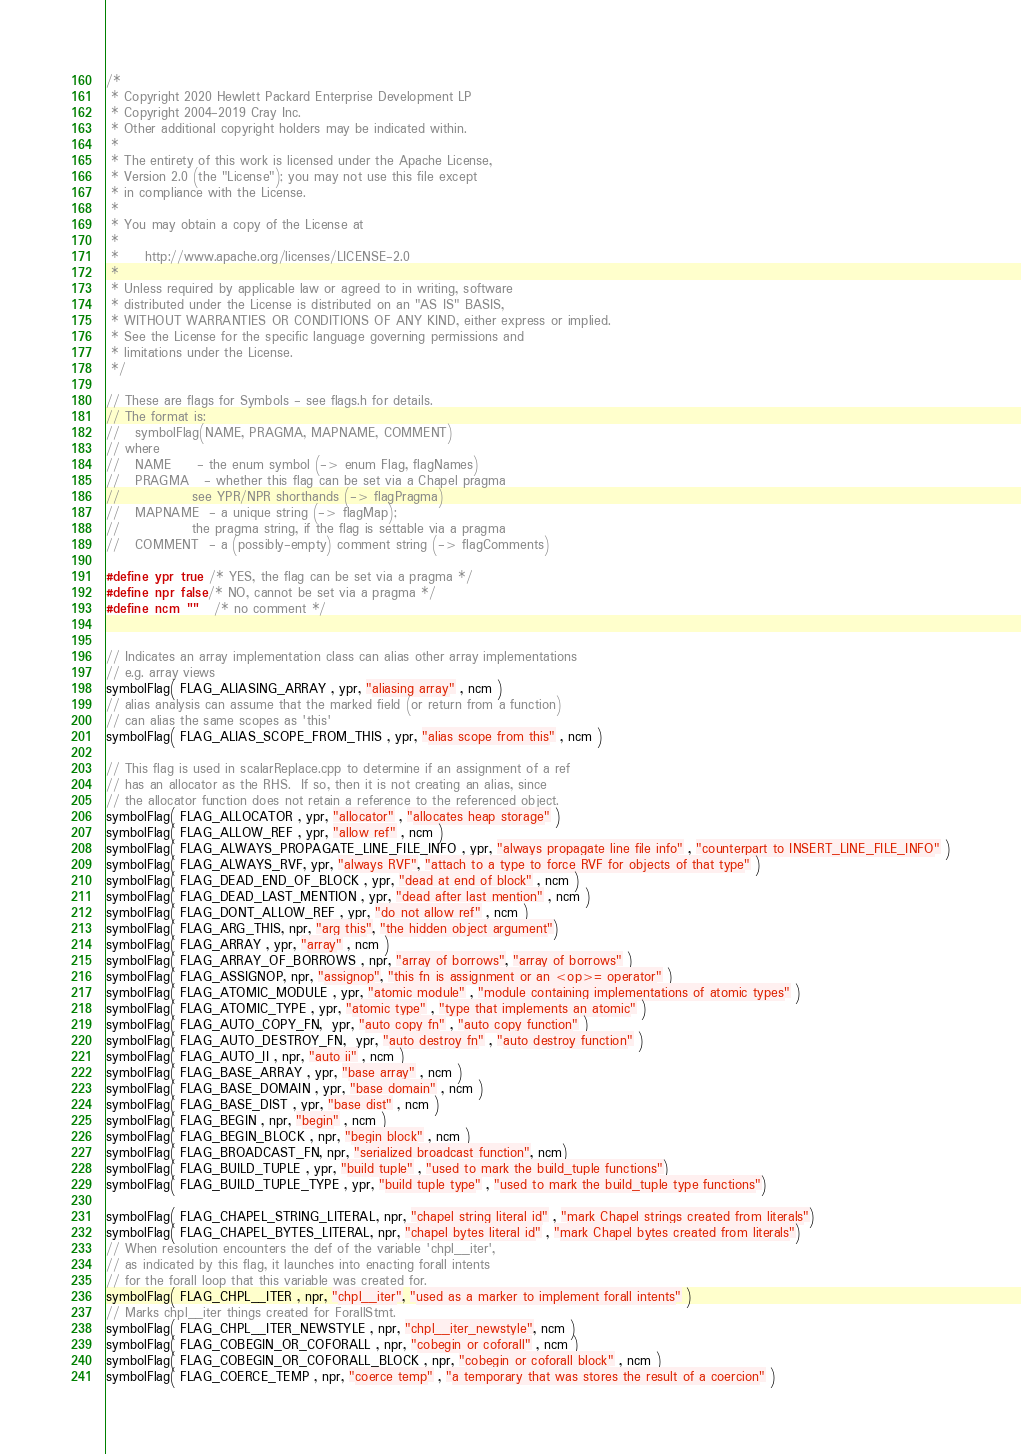<code> <loc_0><loc_0><loc_500><loc_500><_C_>/*
 * Copyright 2020 Hewlett Packard Enterprise Development LP
 * Copyright 2004-2019 Cray Inc.
 * Other additional copyright holders may be indicated within.
 *
 * The entirety of this work is licensed under the Apache License,
 * Version 2.0 (the "License"); you may not use this file except
 * in compliance with the License.
 *
 * You may obtain a copy of the License at
 *
 *     http://www.apache.org/licenses/LICENSE-2.0
 *
 * Unless required by applicable law or agreed to in writing, software
 * distributed under the License is distributed on an "AS IS" BASIS,
 * WITHOUT WARRANTIES OR CONDITIONS OF ANY KIND, either express or implied.
 * See the License for the specific language governing permissions and
 * limitations under the License.
 */

// These are flags for Symbols - see flags.h for details.
// The format is:
//   symbolFlag(NAME, PRAGMA, MAPNAME, COMMENT)
// where
//   NAME     - the enum symbol (-> enum Flag, flagNames)
//   PRAGMA   - whether this flag can be set via a Chapel pragma
//              see YPR/NPR shorthands (-> flagPragma)
//   MAPNAME  - a unique string (-> flagMap);
//              the pragma string, if the flag is settable via a pragma
//   COMMENT  - a (possibly-empty) comment string (-> flagComments)

#define ypr true  /* YES, the flag can be set via a pragma */
#define npr false /* NO, cannot be set via a pragma */
#define ncm ""    /* no comment */


// Indicates an array implementation class can alias other array implementations
// e.g. array views
symbolFlag( FLAG_ALIASING_ARRAY , ypr, "aliasing array" , ncm )
// alias analysis can assume that the marked field (or return from a function)
// can alias the same scopes as 'this'
symbolFlag( FLAG_ALIAS_SCOPE_FROM_THIS , ypr, "alias scope from this" , ncm )

// This flag is used in scalarReplace.cpp to determine if an assignment of a ref
// has an allocator as the RHS.  If so, then it is not creating an alias, since
// the allocator function does not retain a reference to the referenced object.
symbolFlag( FLAG_ALLOCATOR , ypr, "allocator" , "allocates heap storage" )
symbolFlag( FLAG_ALLOW_REF , ypr, "allow ref" , ncm )
symbolFlag( FLAG_ALWAYS_PROPAGATE_LINE_FILE_INFO , ypr, "always propagate line file info" , "counterpart to INSERT_LINE_FILE_INFO" )
symbolFlag( FLAG_ALWAYS_RVF, ypr, "always RVF", "attach to a type to force RVF for objects of that type" )
symbolFlag( FLAG_DEAD_END_OF_BLOCK , ypr, "dead at end of block" , ncm )
symbolFlag( FLAG_DEAD_LAST_MENTION , ypr, "dead after last mention" , ncm )
symbolFlag( FLAG_DONT_ALLOW_REF , ypr, "do not allow ref" , ncm )
symbolFlag( FLAG_ARG_THIS, npr, "arg this", "the hidden object argument")
symbolFlag( FLAG_ARRAY , ypr, "array" , ncm )
symbolFlag( FLAG_ARRAY_OF_BORROWS , npr, "array of borrows", "array of borrows" )
symbolFlag( FLAG_ASSIGNOP, npr, "assignop", "this fn is assignment or an <op>= operator" )
symbolFlag( FLAG_ATOMIC_MODULE , ypr, "atomic module" , "module containing implementations of atomic types" )
symbolFlag( FLAG_ATOMIC_TYPE , ypr, "atomic type" , "type that implements an atomic" )
symbolFlag( FLAG_AUTO_COPY_FN,  ypr, "auto copy fn" , "auto copy function" )
symbolFlag( FLAG_AUTO_DESTROY_FN,  ypr, "auto destroy fn" , "auto destroy function" )
symbolFlag( FLAG_AUTO_II , npr, "auto ii" , ncm )
symbolFlag( FLAG_BASE_ARRAY , ypr, "base array" , ncm )
symbolFlag( FLAG_BASE_DOMAIN , ypr, "base domain" , ncm )
symbolFlag( FLAG_BASE_DIST , ypr, "base dist" , ncm )
symbolFlag( FLAG_BEGIN , npr, "begin" , ncm )
symbolFlag( FLAG_BEGIN_BLOCK , npr, "begin block" , ncm )
symbolFlag( FLAG_BROADCAST_FN, npr, "serialized broadcast function", ncm)
symbolFlag( FLAG_BUILD_TUPLE , ypr, "build tuple" , "used to mark the build_tuple functions")
symbolFlag( FLAG_BUILD_TUPLE_TYPE , ypr, "build tuple type" , "used to mark the build_tuple type functions")

symbolFlag( FLAG_CHAPEL_STRING_LITERAL, npr, "chapel string literal id" , "mark Chapel strings created from literals")
symbolFlag( FLAG_CHAPEL_BYTES_LITERAL, npr, "chapel bytes literal id" , "mark Chapel bytes created from literals")
// When resolution encounters the def of the variable 'chpl__iter',
// as indicated by this flag, it launches into enacting forall intents
// for the forall loop that this variable was created for.
symbolFlag( FLAG_CHPL__ITER , npr, "chpl__iter", "used as a marker to implement forall intents" )
// Marks chpl__iter things created for ForallStmt.
symbolFlag( FLAG_CHPL__ITER_NEWSTYLE , npr, "chpl__iter_newstyle", ncm )
symbolFlag( FLAG_COBEGIN_OR_COFORALL , npr, "cobegin or coforall" , ncm )
symbolFlag( FLAG_COBEGIN_OR_COFORALL_BLOCK , npr, "cobegin or coforall block" , ncm )
symbolFlag( FLAG_COERCE_TEMP , npr, "coerce temp" , "a temporary that was stores the result of a coercion" )</code> 